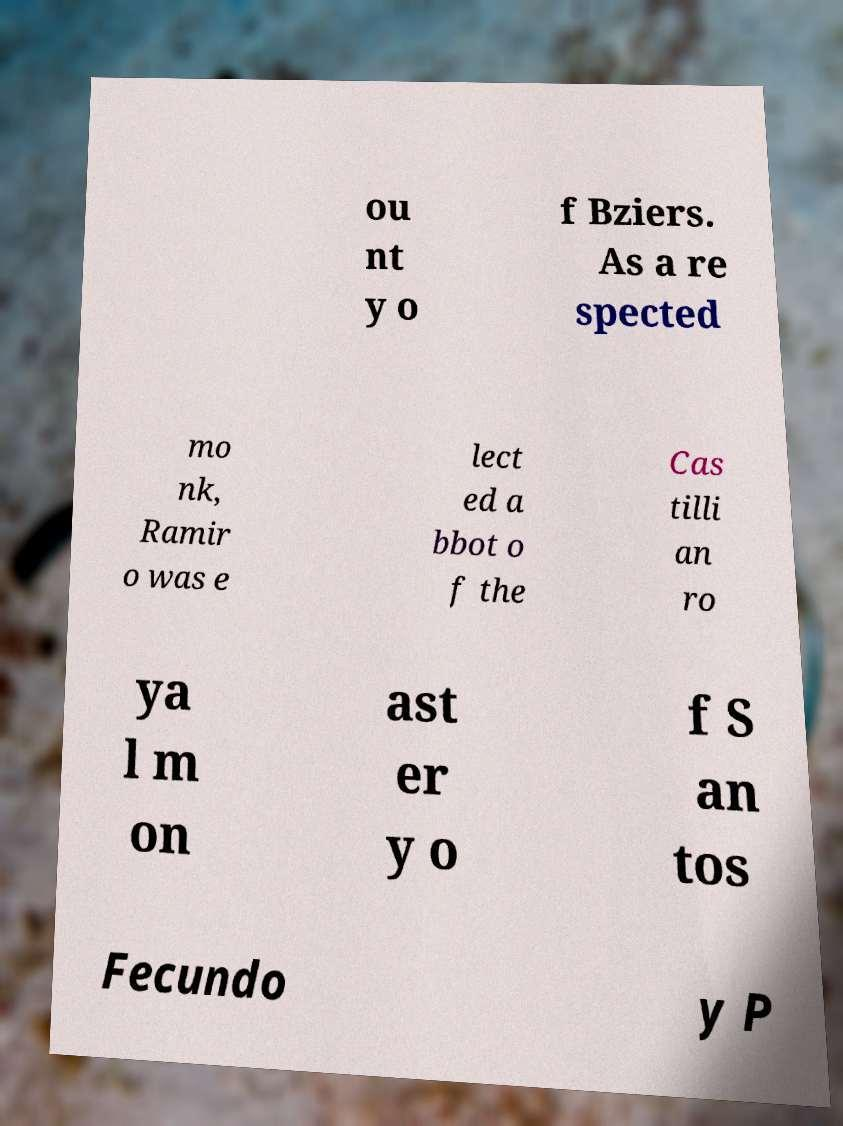What messages or text are displayed in this image? I need them in a readable, typed format. ou nt y o f Bziers. As a re spected mo nk, Ramir o was e lect ed a bbot o f the Cas tilli an ro ya l m on ast er y o f S an tos Fecundo y P 